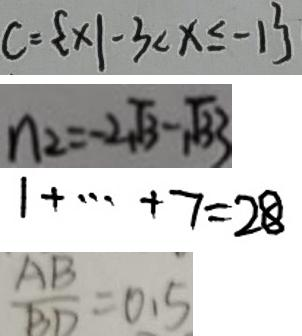<formula> <loc_0><loc_0><loc_500><loc_500>C = \{ x \vert - 3 < x \leq - 1 \} 
 n _ { 2 } = - 2 \sqrt { 3 } - \sqrt { 3 3 } 
 1 + \cdots + 7 = 2 8 
 \frac { A B } { B D } = 0 . 5</formula> 